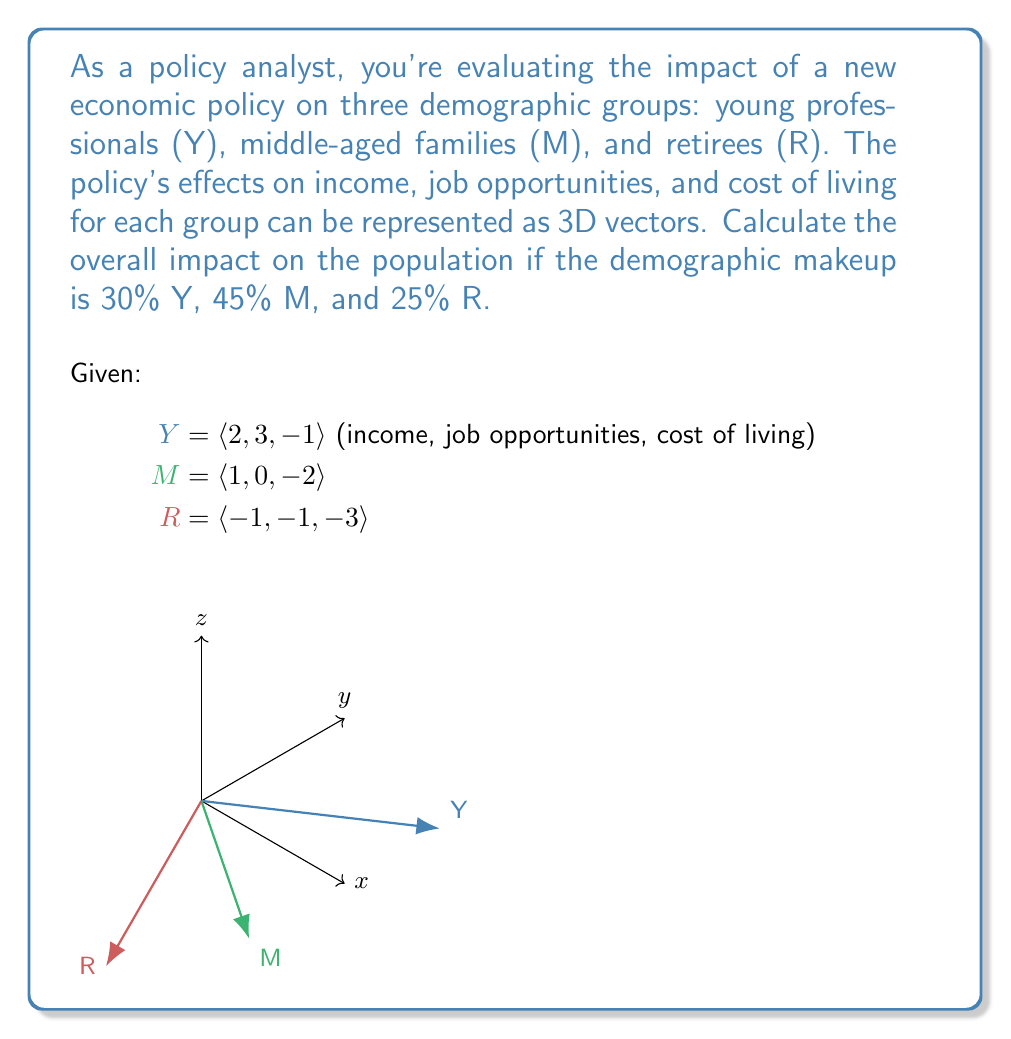Teach me how to tackle this problem. To solve this problem, we'll use vector addition and scalar multiplication:

1) First, we need to scale each vector by its demographic percentage:
   Y': $0.30 \cdot \langle 2, 3, -1 \rangle = \langle 0.6, 0.9, -0.3 \rangle$
   M': $0.45 \cdot \langle 1, 0, -2 \rangle = \langle 0.45, 0, -0.9 \rangle$
   R': $0.25 \cdot \langle -1, -1, -3 \rangle = \langle -0.25, -0.25, -0.75 \rangle$

2) Now, we add these scaled vectors:
   Overall Impact = Y' + M' + R'
   $= \langle 0.6, 0.9, -0.3 \rangle + \langle 0.45, 0, -0.9 \rangle + \langle -0.25, -0.25, -0.75 \rangle$

3) Adding the components:
   $= \langle 0.6 + 0.45 - 0.25, 0.9 + 0 - 0.25, -0.3 - 0.9 - 0.75 \rangle$
   $= \langle 0.8, 0.65, -1.95 \rangle$

4) Interpreting the result:
   - Income impact: slightly positive (0.8)
   - Job opportunities: moderately positive (0.65)
   - Cost of living: significantly decreased (-1.95)
Answer: $\langle 0.8, 0.65, -1.95 \rangle$ 